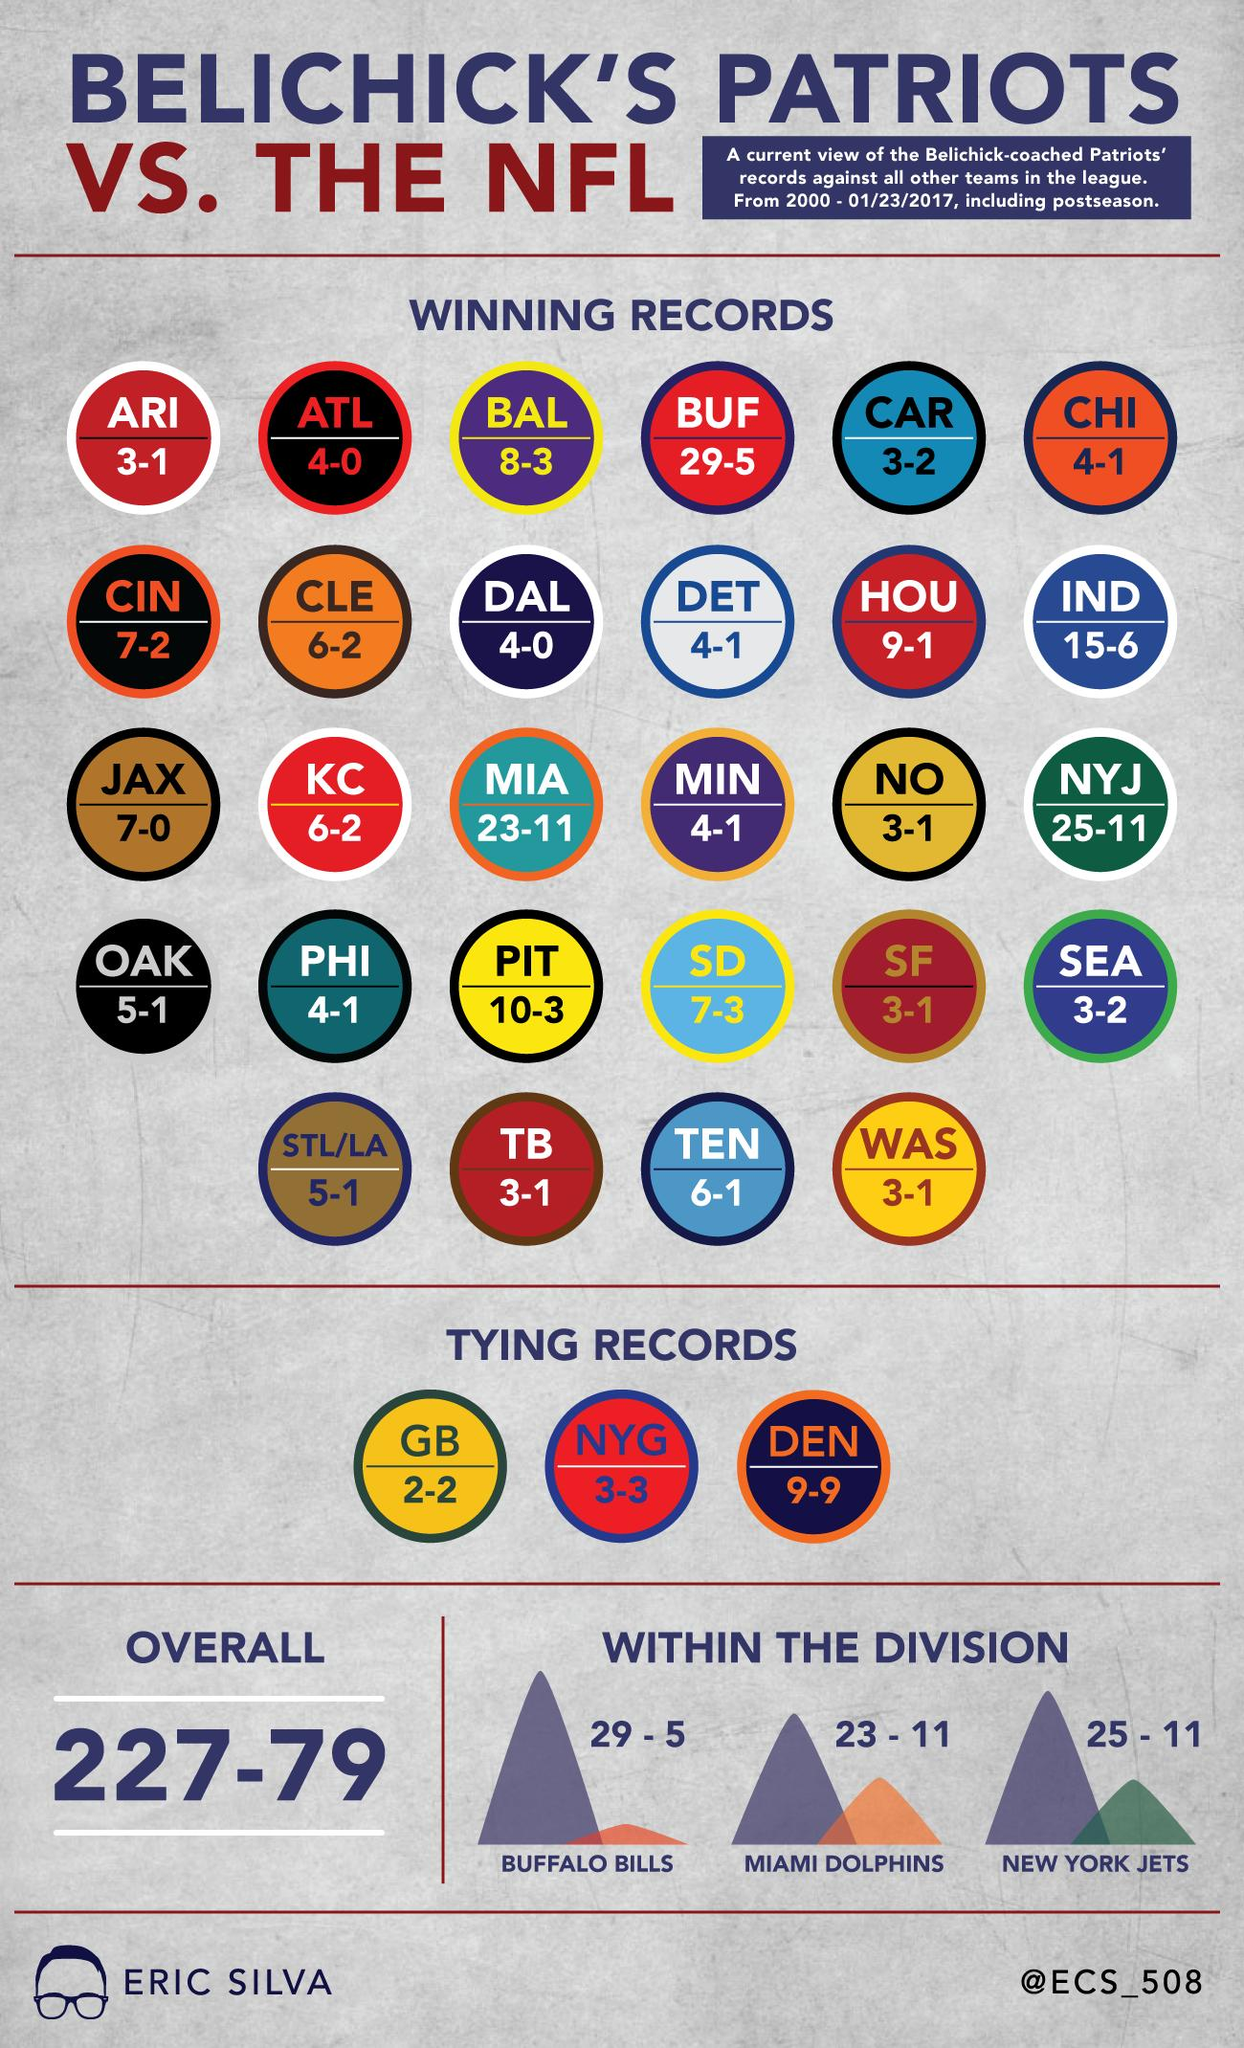Give some essential details in this illustration. In 23 games, the Patriots failed to score more than 10 points. During the matches where the Patriots played against Buffalo Bills, Miami Dolphins, and New York Jets, the score of the Patriots was more than 20 points in all of the games. 